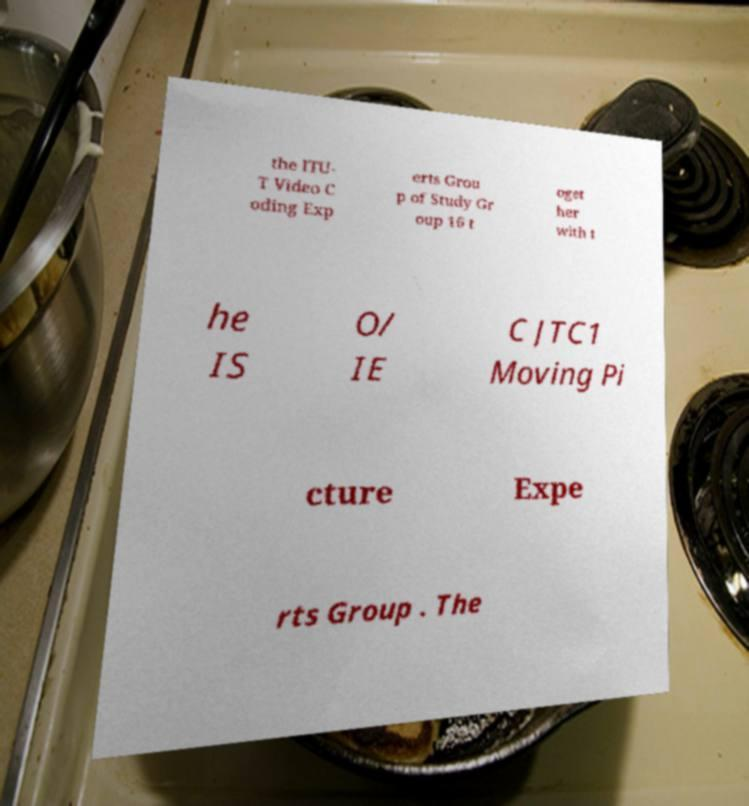Could you assist in decoding the text presented in this image and type it out clearly? the ITU- T Video C oding Exp erts Grou p of Study Gr oup 16 t oget her with t he IS O/ IE C JTC1 Moving Pi cture Expe rts Group . The 